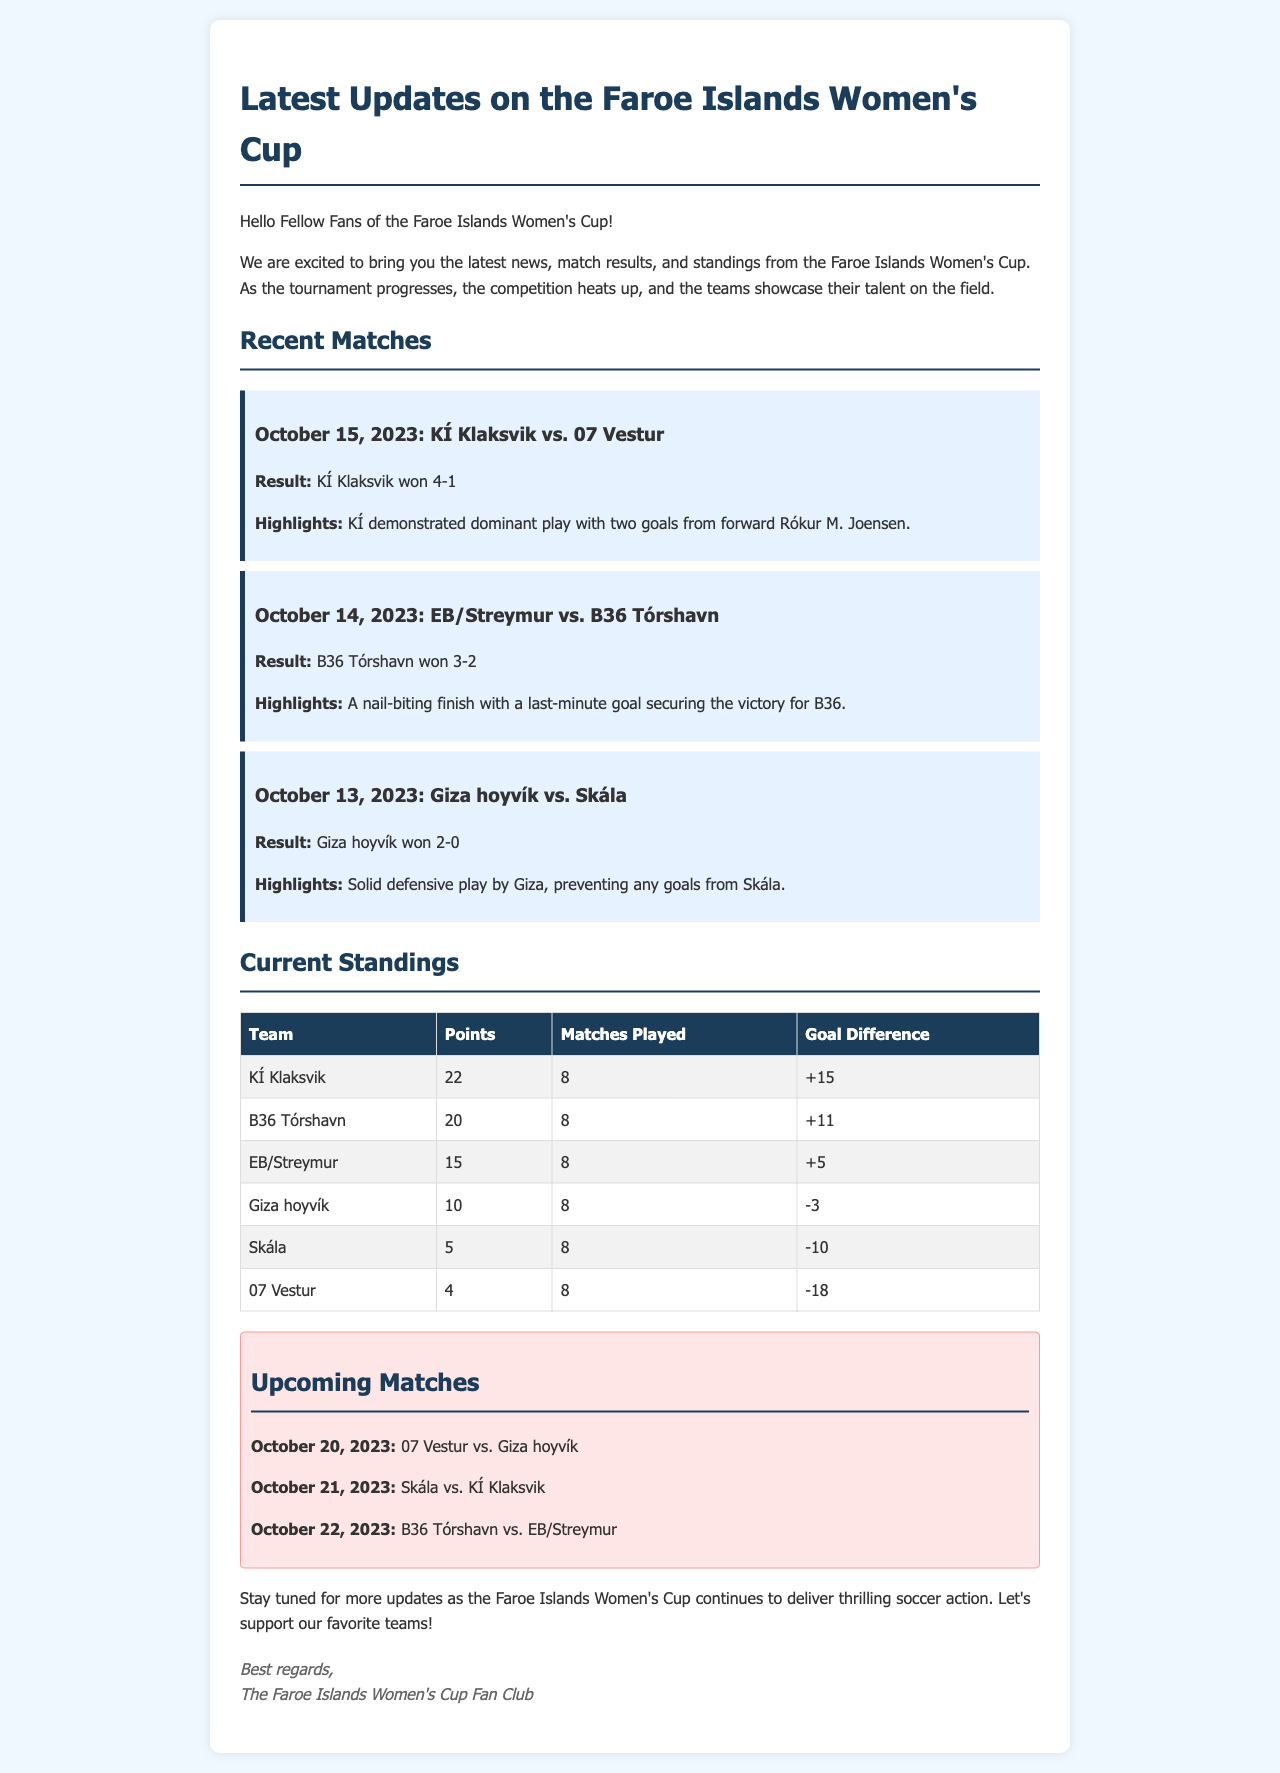What was the result of the match between KÍ Klaksvik and 07 Vestur? The result is mentioned in the match section where KÍ Klaksvik won against 07 Vestur.
Answer: KÍ Klaksvik won 4-1 Who scored two goals for KÍ Klaksvik? The document highlights that forward Rókur M. Joensen scored two goals.
Answer: Rókur M. Joensen How many goals did B36 Tórshavn win by against EB/Streymur? The match description indicates B36 Tórshavn won 3-2, which shows a goal difference of 1.
Answer: 1 What position is KÍ Klaksvik in the current standings? The standings show the team with the highest points is at the top, and KÍ Klaksvik has the most points.
Answer: 1st How many points does Giza hoyvík have in the standings? The standings table presents Giza hoyvík's points as 10.
Answer: 10 Which team has a negative goal difference? Reviewing the standings reveals that both Skála and 07 Vestur have negative goal differences.
Answer: Skála and 07 Vestur When is the upcoming match between 07 Vestur and Giza hoyvík? The upcoming matches section lists the date of the 07 Vestur vs. Giza hoyvík match.
Answer: October 20, 2023 What is the total number of matches played by all teams? Each team has played 8 matches, and there are 6 teams, indicating the total matches played in the standings.
Answer: 48 